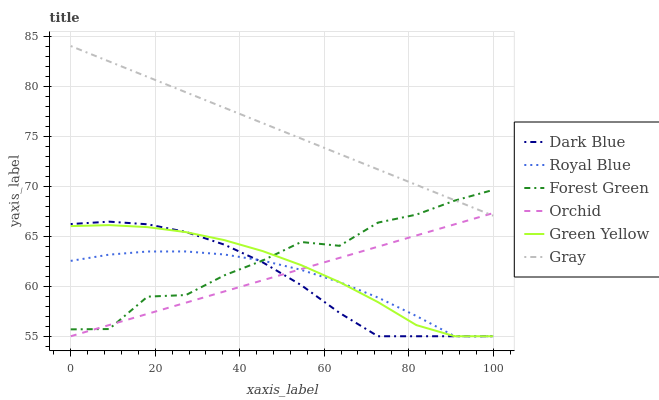Does Royal Blue have the minimum area under the curve?
Answer yes or no. Yes. Does Gray have the maximum area under the curve?
Answer yes or no. Yes. Does Dark Blue have the minimum area under the curve?
Answer yes or no. No. Does Dark Blue have the maximum area under the curve?
Answer yes or no. No. Is Gray the smoothest?
Answer yes or no. Yes. Is Forest Green the roughest?
Answer yes or no. Yes. Is Royal Blue the smoothest?
Answer yes or no. No. Is Royal Blue the roughest?
Answer yes or no. No. Does Royal Blue have the lowest value?
Answer yes or no. Yes. Does Forest Green have the lowest value?
Answer yes or no. No. Does Gray have the highest value?
Answer yes or no. Yes. Does Dark Blue have the highest value?
Answer yes or no. No. Is Dark Blue less than Gray?
Answer yes or no. Yes. Is Gray greater than Dark Blue?
Answer yes or no. Yes. Does Orchid intersect Forest Green?
Answer yes or no. Yes. Is Orchid less than Forest Green?
Answer yes or no. No. Is Orchid greater than Forest Green?
Answer yes or no. No. Does Dark Blue intersect Gray?
Answer yes or no. No. 